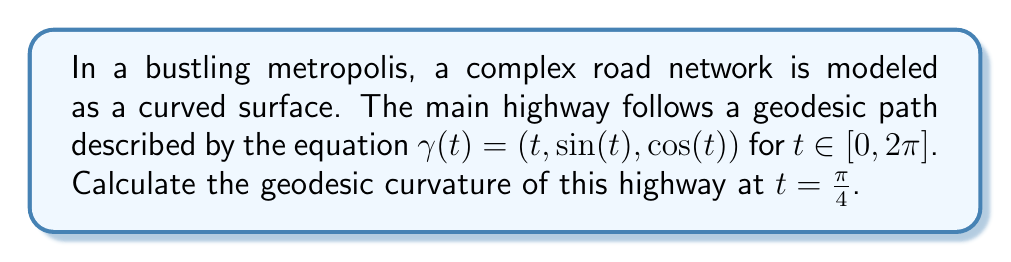Can you answer this question? To find the geodesic curvature, we'll follow these steps:

1) First, we need to calculate the velocity vector $\gamma'(t)$ and acceleration vector $\gamma''(t)$:

   $\gamma'(t) = (1, \cos(t), -\sin(t))$
   $\gamma''(t) = (0, -\sin(t), -\cos(t))$

2) We then calculate the unit tangent vector $T(t)$:

   $T(t) = \frac{\gamma'(t)}{|\gamma'(t)|} = \frac{(1, \cos(t), -\sin(t))}{\sqrt{1 + \cos^2(t) + \sin^2(t)}} = \frac{(1, \cos(t), -\sin(t))}{\sqrt{2}}$

3) Next, we calculate the principal normal vector $N(t)$:

   $N(t) = \frac{\gamma''(t) - (\gamma''(t) \cdot T(t))T(t)}{|\gamma''(t) - (\gamma''(t) \cdot T(t))T(t)|}$

4) The geodesic curvature $\kappa_g$ is given by:

   $\kappa_g = \frac{\det(\gamma'(t), \gamma''(t), N(t))}{|\gamma'(t)|^2}$

5) At $t = \frac{\pi}{4}$, we have:

   $\gamma'(\frac{\pi}{4}) = (1, \frac{\sqrt{2}}{2}, -\frac{\sqrt{2}}{2})$
   $\gamma''(\frac{\pi}{4}) = (0, -\frac{\sqrt{2}}{2}, -\frac{\sqrt{2}}{2})$
   $T(\frac{\pi}{4}) = (\frac{1}{\sqrt{2}}, \frac{1}{2}, -\frac{1}{2})$

6) Calculating $N(\frac{\pi}{4})$:

   $N(\frac{\pi}{4}) = (0, -\frac{\sqrt{2}}{2}, \frac{\sqrt{2}}{2})$

7) Now we can calculate the determinant:

   $\det(\gamma'(\frac{\pi}{4}), \gamma''(\frac{\pi}{4}), N(\frac{\pi}{4})) = 0$

8) Therefore, the geodesic curvature at $t = \frac{\pi}{4}$ is:

   $\kappa_g = \frac{0}{2} = 0$
Answer: $0$ 